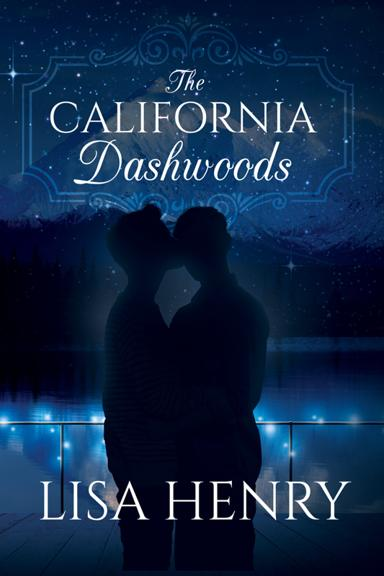What is the title of the book mentioned in the image? The title of the book shown in the image is 'The California Dashwoods,' authored by Lisa Henry. The cover features a romantic and mysterious nighttime scene that hints at the themes of the book. 